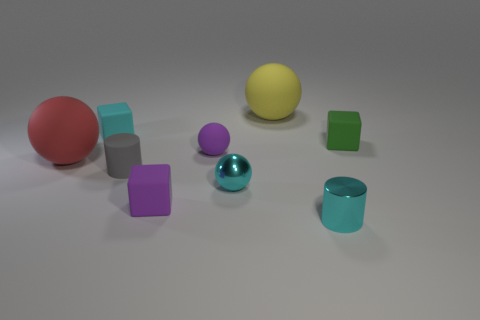Subtract all tiny purple balls. How many balls are left? 3 Subtract all cyan cylinders. How many cylinders are left? 1 Add 1 cyan cubes. How many objects exist? 10 Subtract all cylinders. How many objects are left? 7 Subtract 0 yellow blocks. How many objects are left? 9 Subtract 1 balls. How many balls are left? 3 Subtract all yellow cylinders. Subtract all blue blocks. How many cylinders are left? 2 Subtract all large red objects. Subtract all tiny cyan shiny things. How many objects are left? 6 Add 8 tiny metallic cylinders. How many tiny metallic cylinders are left? 9 Add 6 large cylinders. How many large cylinders exist? 6 